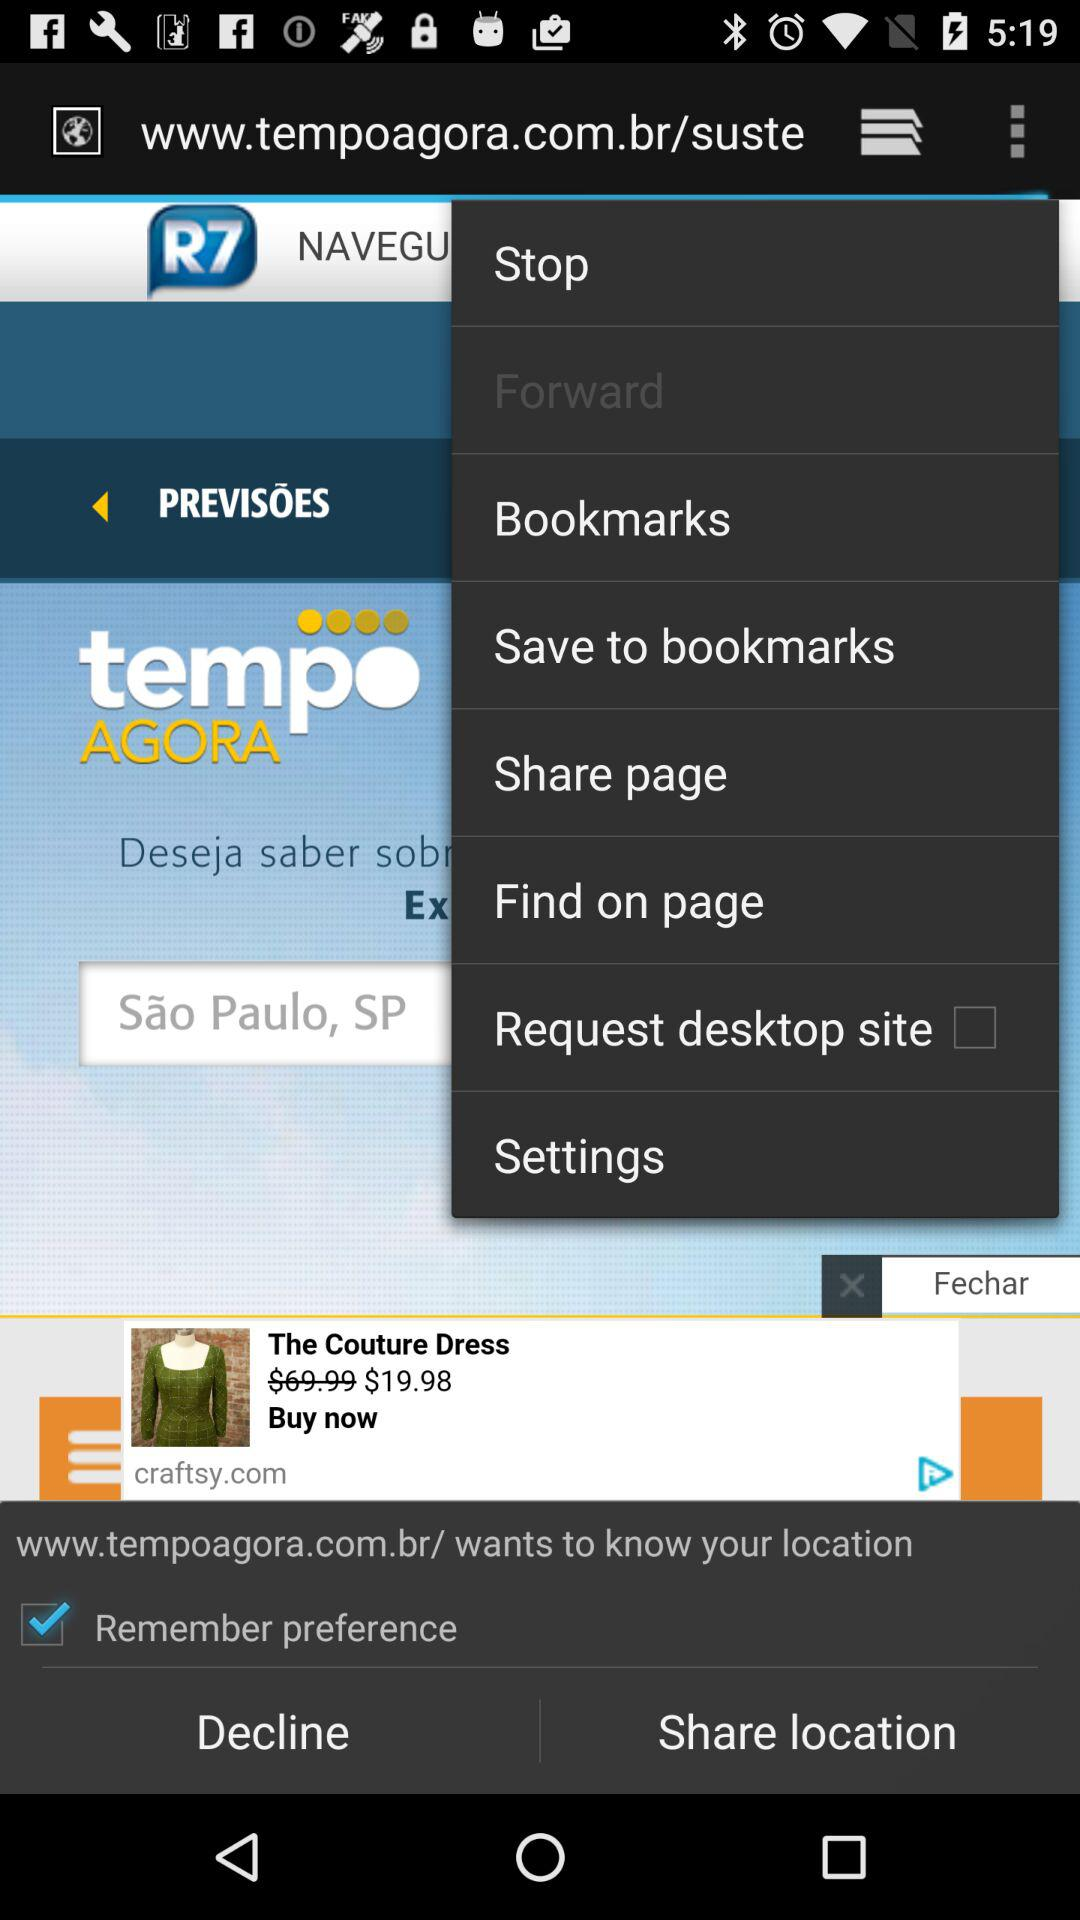What is the current status of the "Remember preference" setting? The current status of the "Remember preference" setting is "on". 